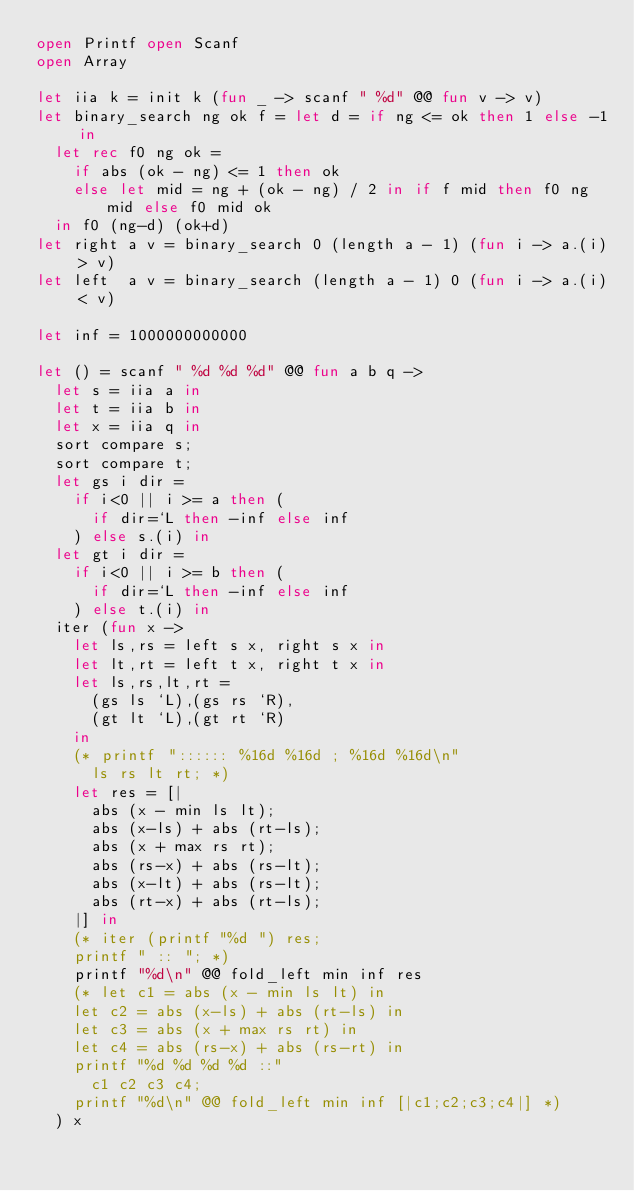<code> <loc_0><loc_0><loc_500><loc_500><_OCaml_>open Printf open Scanf
open Array

let iia k = init k (fun _ -> scanf " %d" @@ fun v -> v)
let binary_search ng ok f = let d = if ng <= ok then 1 else -1 in
  let rec f0 ng ok =
    if abs (ok - ng) <= 1 then ok
    else let mid = ng + (ok - ng) / 2 in if f mid then f0 ng mid else f0 mid ok
  in f0 (ng-d) (ok+d)
let right a v = binary_search 0 (length a - 1) (fun i -> a.(i) > v)
let left  a v = binary_search (length a - 1) 0 (fun i -> a.(i) < v)

let inf = 1000000000000

let () = scanf " %d %d %d" @@ fun a b q ->
  let s = iia a in
  let t = iia b in
  let x = iia q in
  sort compare s;
  sort compare t;
  let gs i dir =
    if i<0 || i >= a then (
      if dir=`L then -inf else inf
    ) else s.(i) in
  let gt i dir =
    if i<0 || i >= b then (
      if dir=`L then -inf else inf
    ) else t.(i) in
  iter (fun x ->
    let ls,rs = left s x, right s x in
    let lt,rt = left t x, right t x in
    let ls,rs,lt,rt =
      (gs ls `L),(gs rs `R),
      (gt lt `L),(gt rt `R)
    in
    (* printf ":::::: %16d %16d ; %16d %16d\n"
      ls rs lt rt; *)
    let res = [|
      abs (x - min ls lt);
      abs (x-ls) + abs (rt-ls);
      abs (x + max rs rt);
      abs (rs-x) + abs (rs-lt);
      abs (x-lt) + abs (rs-lt);
      abs (rt-x) + abs (rt-ls);
    |] in
    (* iter (printf "%d ") res;
    printf " :: "; *)
    printf "%d\n" @@ fold_left min inf res
    (* let c1 = abs (x - min ls lt) in
    let c2 = abs (x-ls) + abs (rt-ls) in
    let c3 = abs (x + max rs rt) in
    let c4 = abs (rs-x) + abs (rs-rt) in
    printf "%d %d %d %d ::"
      c1 c2 c3 c4;
    printf "%d\n" @@ fold_left min inf [|c1;c2;c3;c4|] *)
  ) x


</code> 